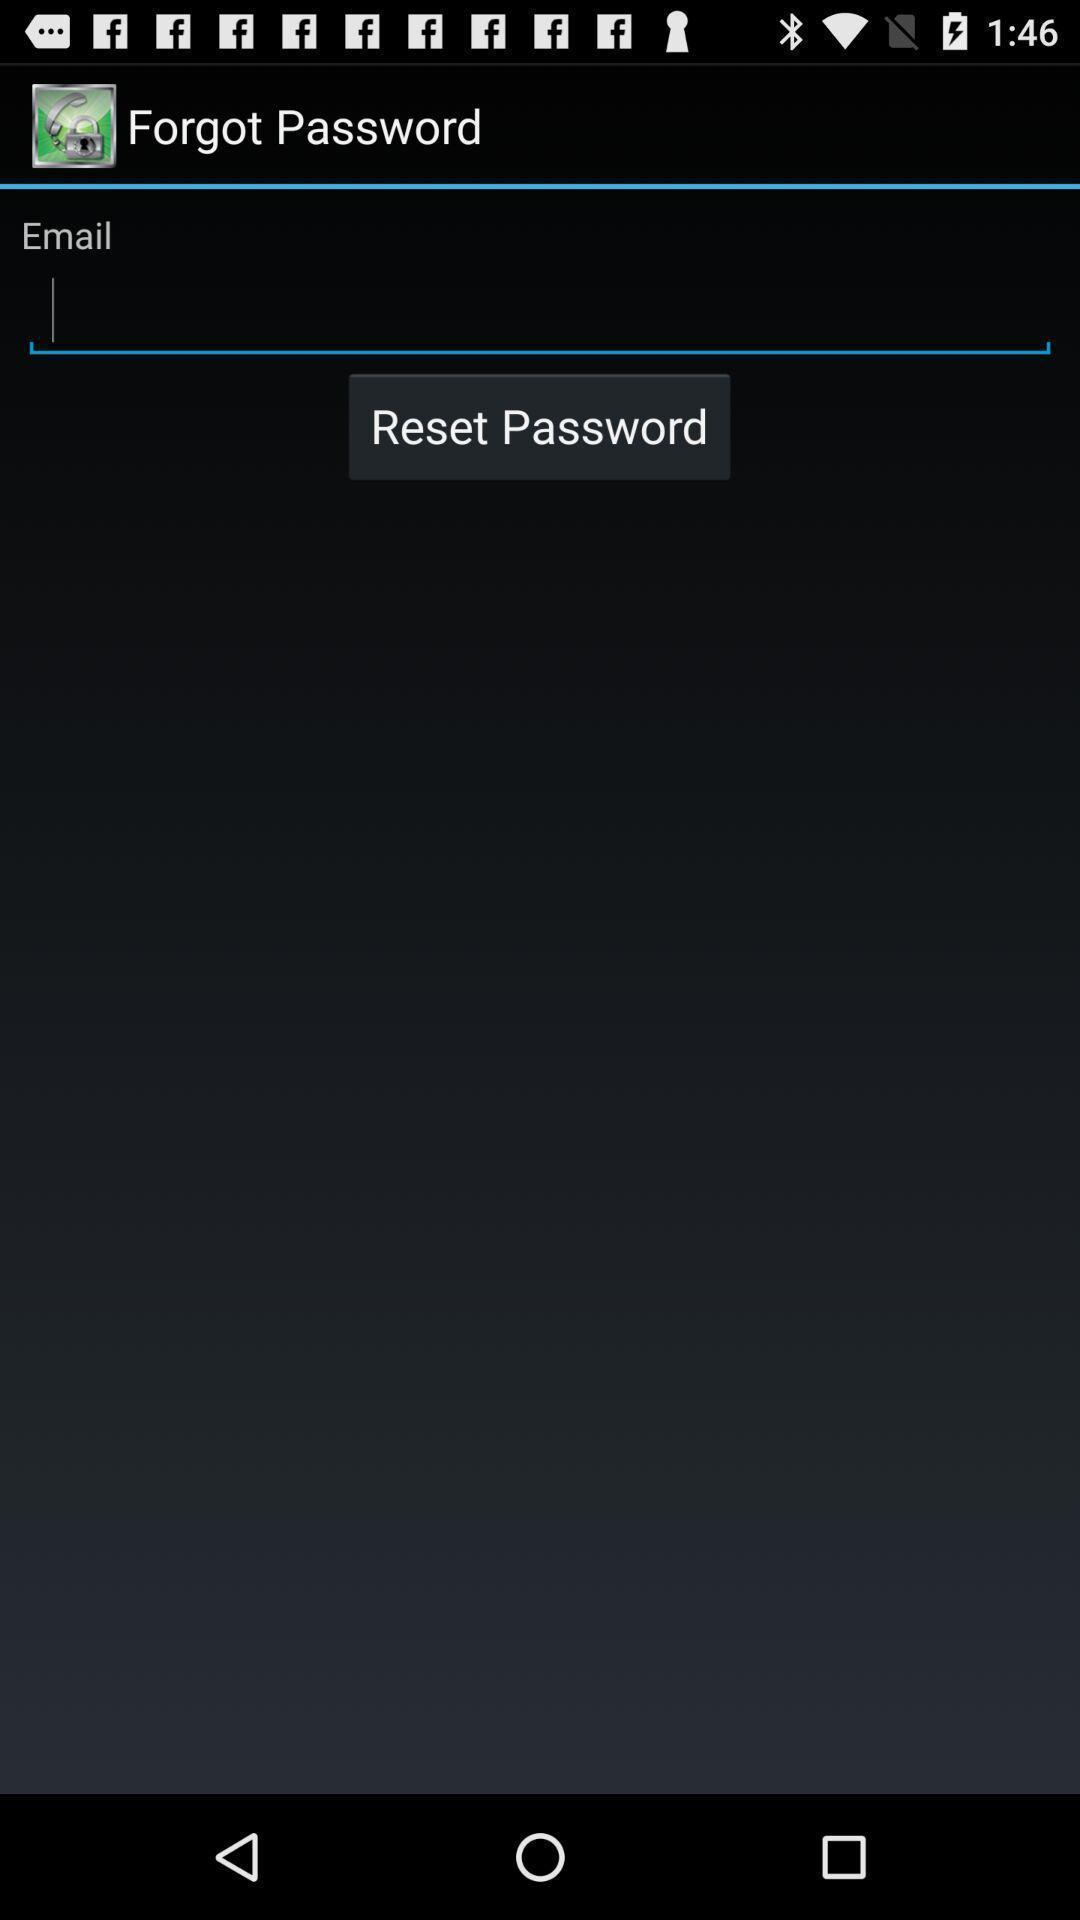Provide a textual representation of this image. Screen displaying contents in authentication page. 